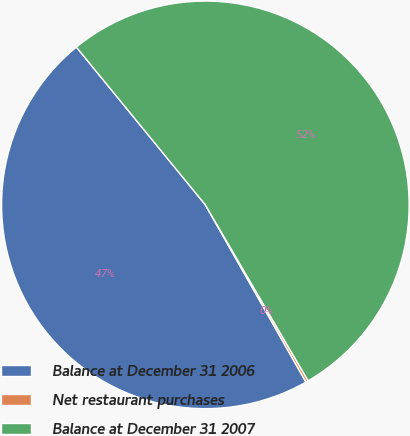<chart> <loc_0><loc_0><loc_500><loc_500><pie_chart><fcel>Balance at December 31 2006<fcel>Net restaurant purchases<fcel>Balance at December 31 2007<nl><fcel>47.3%<fcel>0.2%<fcel>52.49%<nl></chart> 